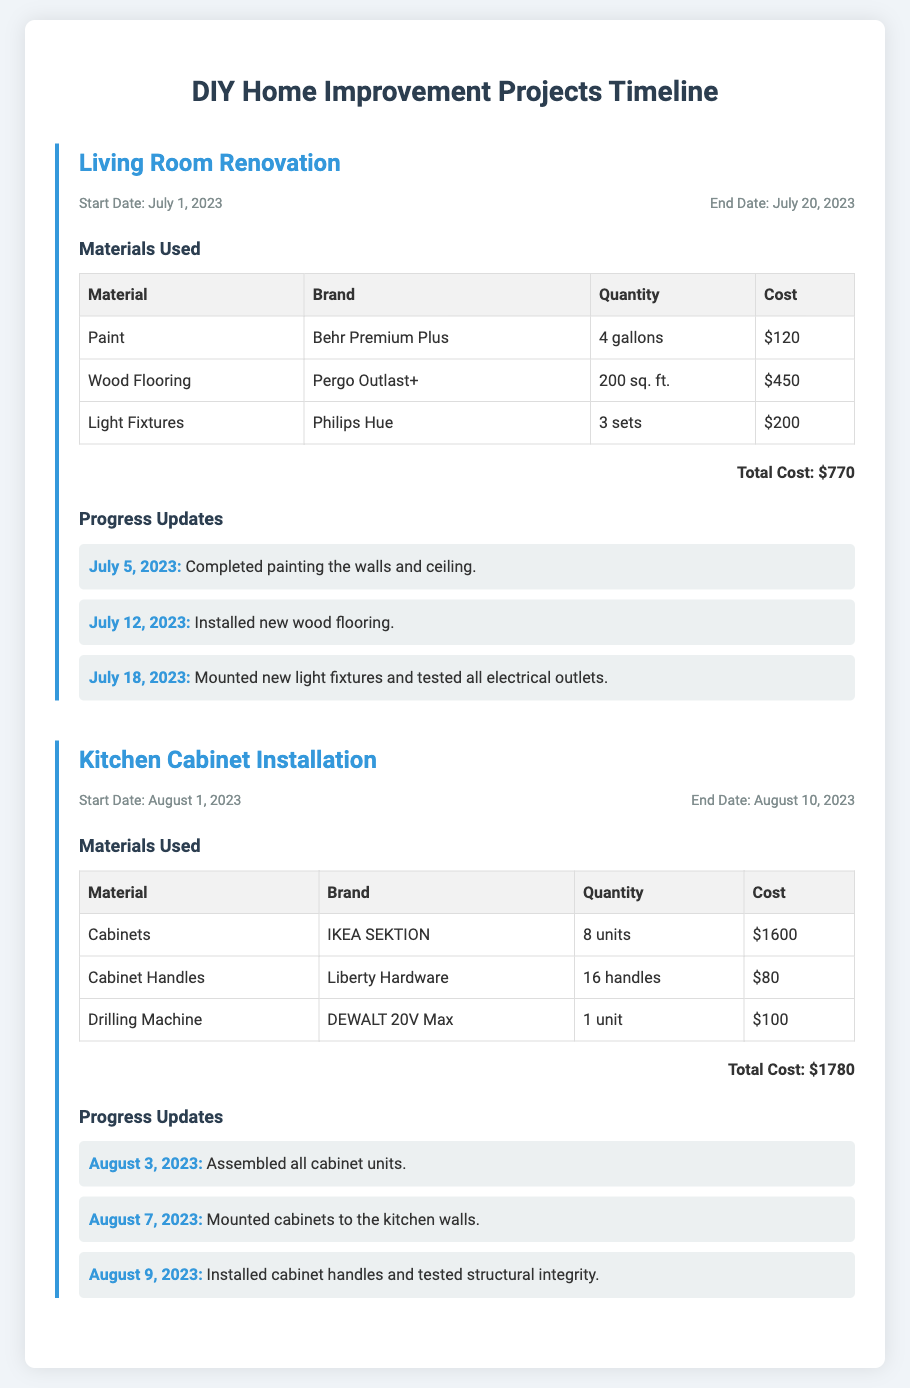What is the total cost of materials for the Living Room Renovation? The total cost of materials is calculated by adding the costs of each material used for the Living Room Renovation, which amounts to $120 + $450 + $200 = $770.
Answer: $770 What is the brand of the light fixtures used in the Living Room Renovation? The brand of the light fixtures listed in the materials used for the Living Room Renovation is Philips Hue.
Answer: Philips Hue What date did the Kitchen Cabinet Installation start? The start date for the Kitchen Cabinet Installation is explicitly stated in the document as August 1, 2023.
Answer: August 1, 2023 How many units of cabinets were used in the Kitchen Cabinet Installation? The document specifies that 8 units of cabinets were used for the Kitchen Cabinet Installation.
Answer: 8 units What was the last update provided for the Living Room Renovation? The last update for the Living Room Renovation indicates that on July 18, 2023, new light fixtures were mounted and electrical outlets were tested.
Answer: July 18, 2023 What is the quantity of wood flooring used in the Living Room Renovation? The document states that 200 square feet of wood flooring was used for the Living Room Renovation.
Answer: 200 sq. ft How many cabinet handles were used in the Kitchen Cabinet Installation? According to the materials used listed for the Kitchen Cabinet Installation, 16 cabinet handles were used.
Answer: 16 handles What was the total cost of materials for the Kitchen Cabinet Installation? The total cost of materials listed for the Kitchen Cabinet Installation sums up to $1600 + $80 + $100 = $1780.
Answer: $1780 